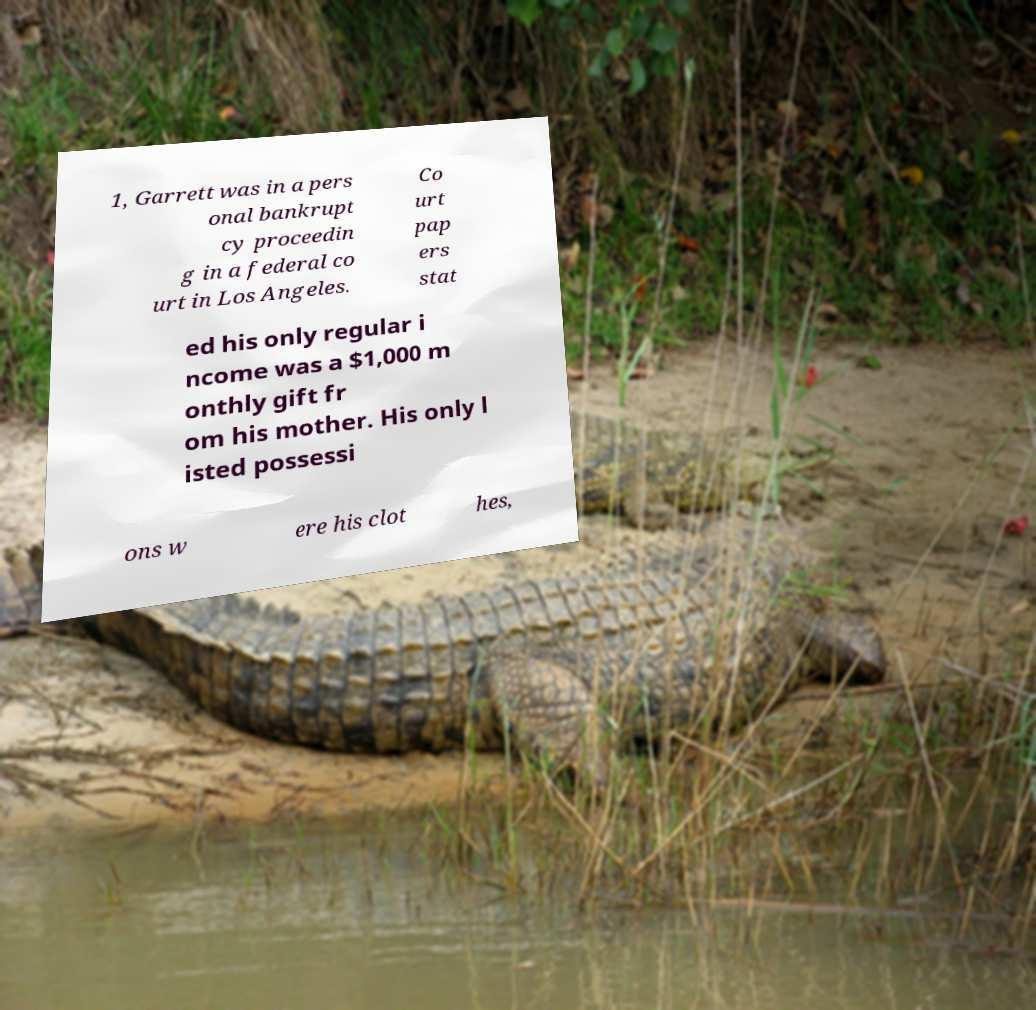Please identify and transcribe the text found in this image. 1, Garrett was in a pers onal bankrupt cy proceedin g in a federal co urt in Los Angeles. Co urt pap ers stat ed his only regular i ncome was a $1,000 m onthly gift fr om his mother. His only l isted possessi ons w ere his clot hes, 